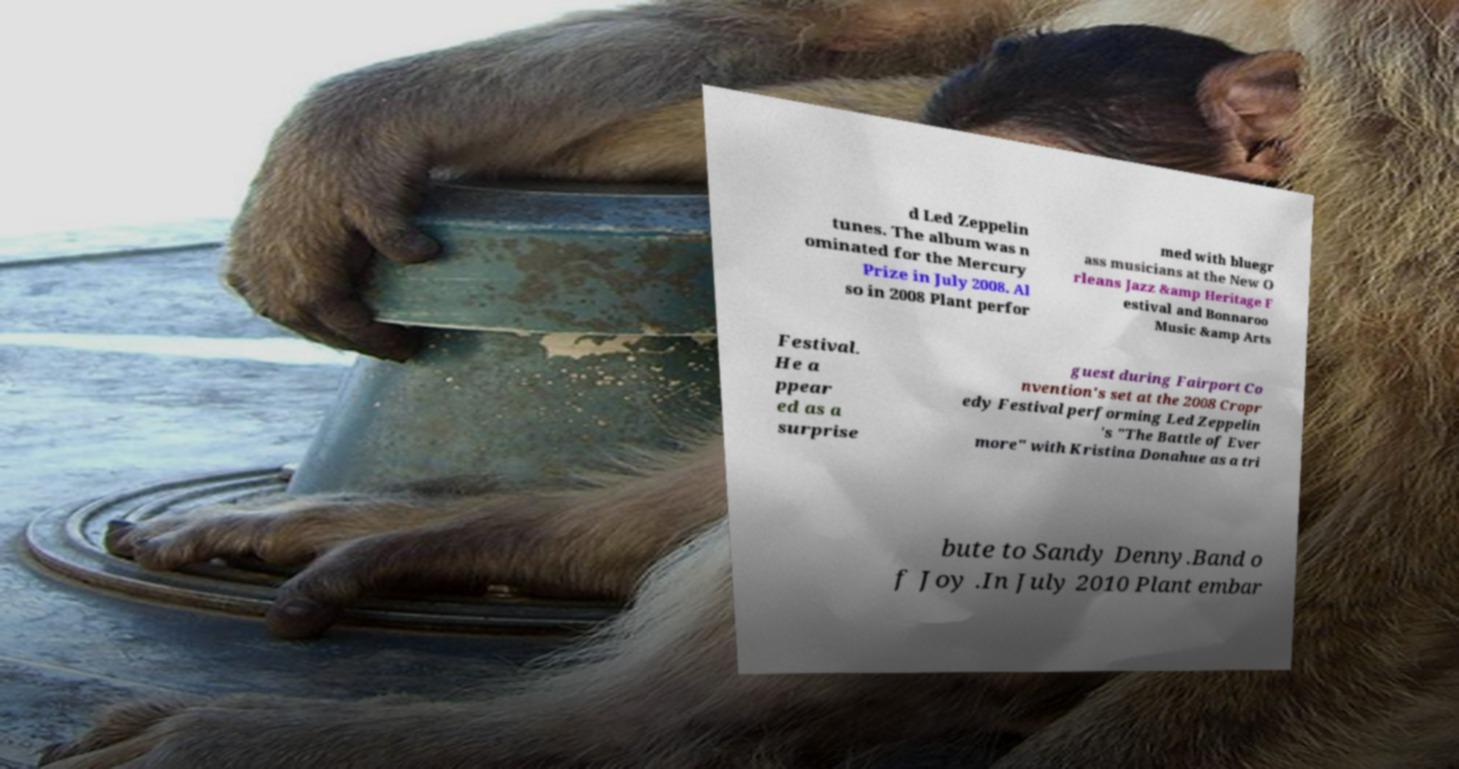What messages or text are displayed in this image? I need them in a readable, typed format. d Led Zeppelin tunes. The album was n ominated for the Mercury Prize in July 2008. Al so in 2008 Plant perfor med with bluegr ass musicians at the New O rleans Jazz &amp Heritage F estival and Bonnaroo Music &amp Arts Festival. He a ppear ed as a surprise guest during Fairport Co nvention's set at the 2008 Cropr edy Festival performing Led Zeppelin 's "The Battle of Ever more" with Kristina Donahue as a tri bute to Sandy Denny.Band o f Joy .In July 2010 Plant embar 